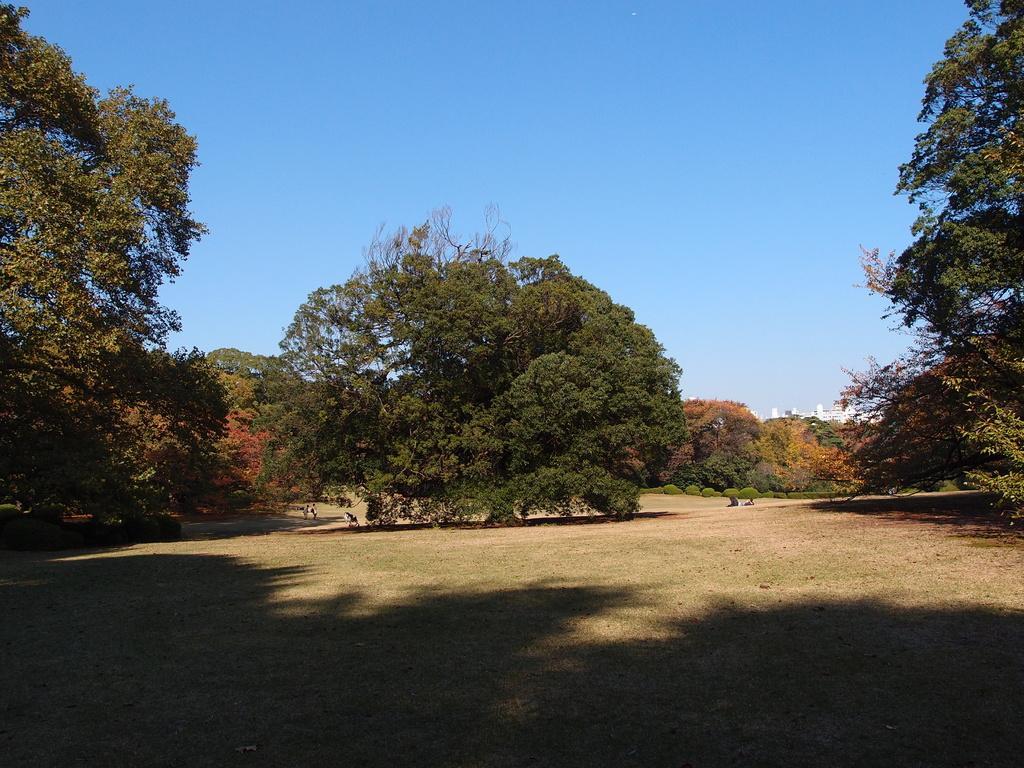In one or two sentences, can you explain what this image depicts? In this image we can see a plain ground and in the middle of the image there is a tree and some other trees are on the left side and on the right side. The background is the sky. 